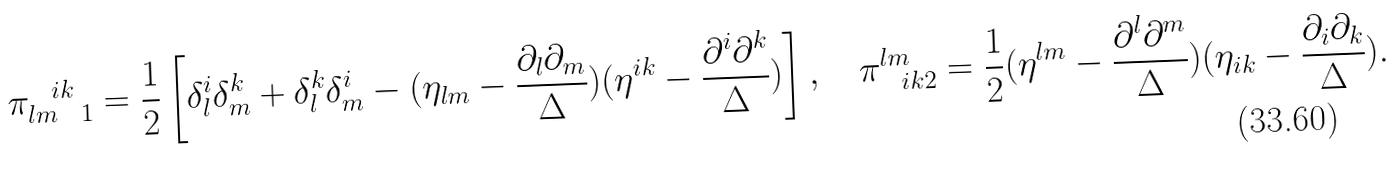Convert formula to latex. <formula><loc_0><loc_0><loc_500><loc_500>\pi _ { l m \ \ 1 } ^ { \ \ i k } = \frac { 1 } { 2 } \left [ \delta ^ { i } _ { l } \delta ^ { k } _ { m } + \delta ^ { k } _ { l } \delta ^ { i } _ { m } - ( \eta _ { l m } - \frac { \partial _ { l } \partial _ { m } } { \Delta } ) ( \eta ^ { i k } - \frac { \partial ^ { i } \partial ^ { k } } { \Delta } ) \right ] , \quad \pi ^ { l m } _ { \ \ i k 2 } = \frac { 1 } { 2 } ( \eta ^ { l m } - \frac { \partial ^ { l } \partial ^ { m } } { \Delta } ) ( \eta _ { i k } - \frac { \partial _ { i } \partial _ { k } } { \Delta } ) .</formula> 